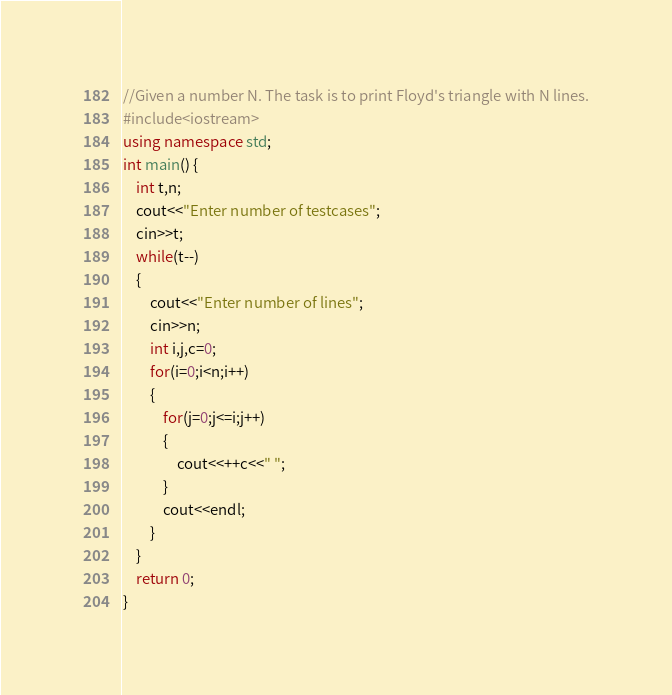Convert code to text. <code><loc_0><loc_0><loc_500><loc_500><_C++_>//Given a number N. The task is to print Floyd's triangle with N lines.
#include<iostream>
using namespace std;
int main() {
	int t,n;
	cout<<"Enter number of testcases";
	cin>>t;
	while(t--)
	{
		cout<<"Enter number of lines";
	    cin>>n;
	    int i,j,c=0;
	    for(i=0;i<n;i++)
	    {
	        for(j=0;j<=i;j++)
	        {
	            cout<<++c<<" ";
	        }
	        cout<<endl;
	    }
	}
	return 0;
}
</code> 